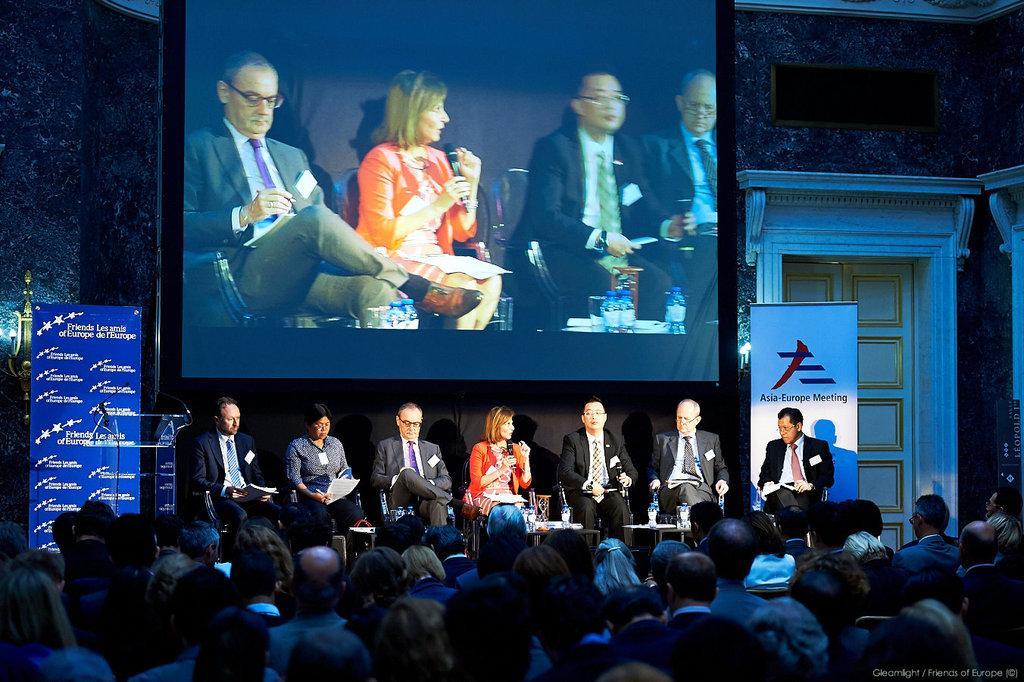Describe this image in one or two sentences. In this image, we can see a group of people sitting. We can also see some banners and a projector screen. There is a wall with a door which is white in color. 